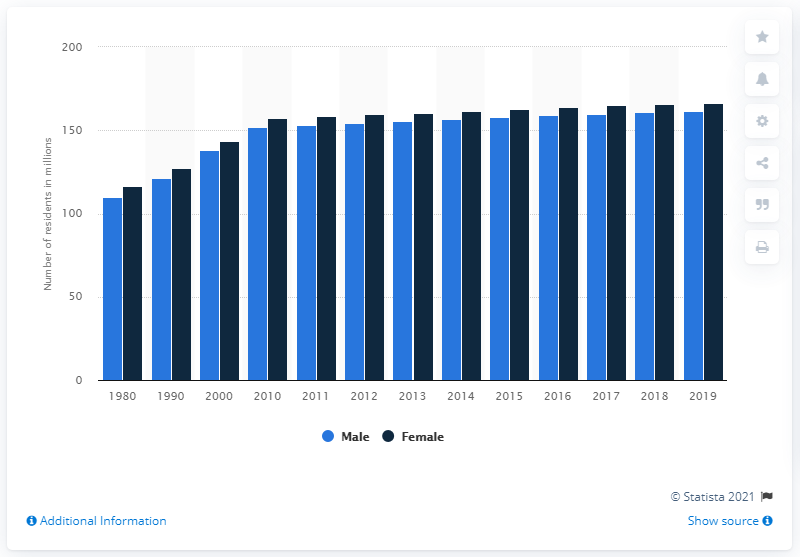Draw attention to some important aspects in this diagram. As of July 1, 2019, it is estimated that there were 166.58 females living in the United States. As of July 1, 2019, it is estimated that there are approximately 161.66 million males living in the United States. 